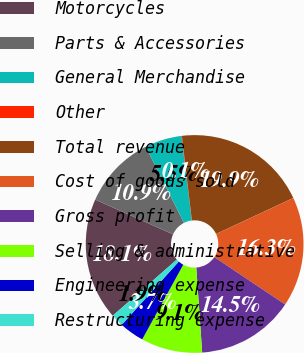Convert chart. <chart><loc_0><loc_0><loc_500><loc_500><pie_chart><fcel>Motorcycles<fcel>Parts & Accessories<fcel>General Merchandise<fcel>Other<fcel>Total revenue<fcel>Cost of goods sold<fcel>Gross profit<fcel>Selling & administrative<fcel>Engineering expense<fcel>Restructuring expense<nl><fcel>18.13%<fcel>10.9%<fcel>5.48%<fcel>0.07%<fcel>19.93%<fcel>16.32%<fcel>14.52%<fcel>9.1%<fcel>3.68%<fcel>1.87%<nl></chart> 